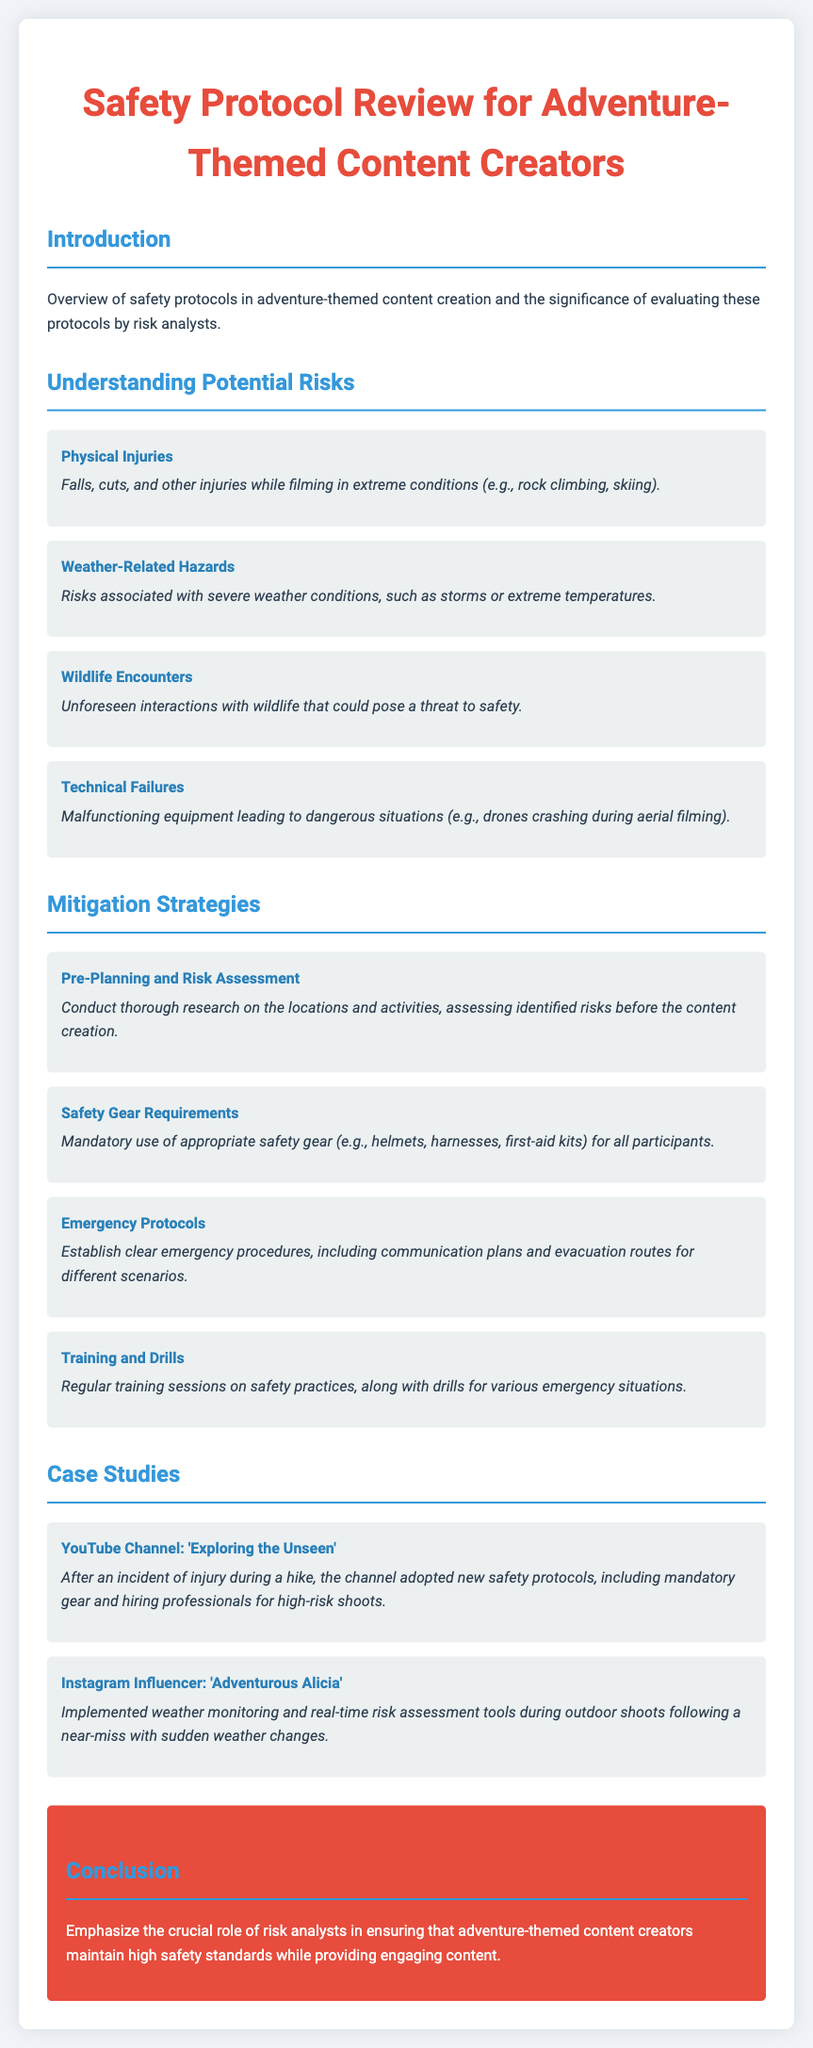What are the potential risks mentioned? The document lists several potential risks, including physical injuries, weather-related hazards, wildlife encounters, and technical failures.
Answer: physical injuries, weather-related hazards, wildlife encounters, technical failures What is one of the mitigation strategies outlined? One of the mitigation strategies is to establish clear emergency procedures, including communication plans and evacuation routes for different scenarios.
Answer: Emergency Protocols How many case studies are provided? The document contains two case studies showcasing different adventure-themed content creators and their safety improvements.
Answer: 2 What is the role of risk analysts emphasized in the conclusion? The conclusion highlights that risk analysts play a crucial role in ensuring that adventure-themed content creators maintain high safety standards.
Answer: Ensure safety standards Which YouTube channel is mentioned in the case studies? The document mentions the YouTube channel 'Exploring the Unseen' as an example in the case studies section.
Answer: Exploring the Unseen What type of content do the creators mentioned in the document focus on? The content creators discussed in the document focus on adventure-themed activities, which can involve inherent risks.
Answer: Adventure-themed content What does the lesson from 'Adventurous Alicia' emphasize? The lesson emphasizes the importance of implementing weather monitoring and real-time risk assessment tools during outdoor shoots.
Answer: Weather monitoring and real-time risk assessment tools What is the document primarily about? The document is a safety protocol review aimed at adventure-themed content creators, focusing on potential risks and mitigation strategies.
Answer: Safety protocol review 